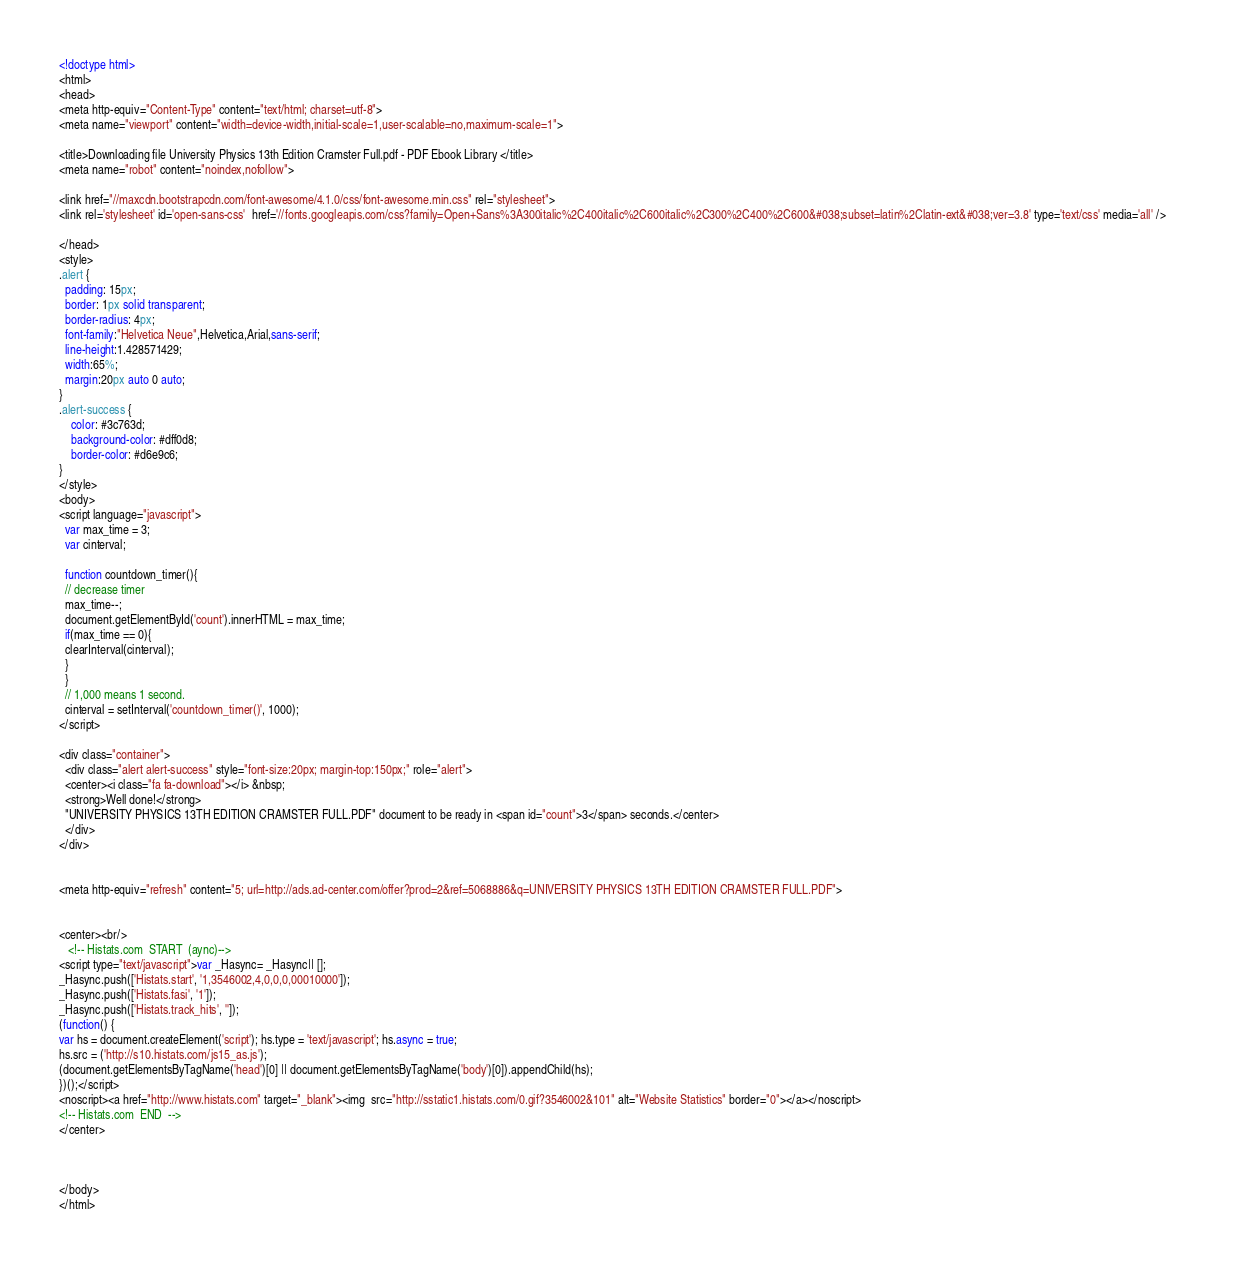Convert code to text. <code><loc_0><loc_0><loc_500><loc_500><_HTML_><!doctype html>
<html>
<head>
<meta http-equiv="Content-Type" content="text/html; charset=utf-8">
<meta name="viewport" content="width=device-width,initial-scale=1,user-scalable=no,maximum-scale=1">

<title>Downloading file University Physics 13th Edition Cramster Full.pdf - PDF Ebook Library </title>
<meta name="robot" content="noindex,nofollow">

<link href="//maxcdn.bootstrapcdn.com/font-awesome/4.1.0/css/font-awesome.min.css" rel="stylesheet">
<link rel='stylesheet' id='open-sans-css'  href='//fonts.googleapis.com/css?family=Open+Sans%3A300italic%2C400italic%2C600italic%2C300%2C400%2C600&#038;subset=latin%2Clatin-ext&#038;ver=3.8' type='text/css' media='all' />	

</head>
<style>
.alert {
  padding: 15px;
  border: 1px solid transparent;
  border-radius: 4px;
  font-family:"Helvetica Neue",Helvetica,Arial,sans-serif;
  line-height:1.428571429;
  width:65%;
  margin:20px auto 0 auto;
}
.alert-success {
	color: #3c763d;
	background-color: #dff0d8;
	border-color: #d6e9c6;
}
</style>
<body>
<script language="javascript">
  var max_time = 3;
  var cinterval;
   
  function countdown_timer(){
  // decrease timer
  max_time--;
  document.getElementById('count').innerHTML = max_time;
  if(max_time == 0){
  clearInterval(cinterval);
  }
  }
  // 1,000 means 1 second.
  cinterval = setInterval('countdown_timer()', 1000);
</script>

<div class="container">
  <div class="alert alert-success" style="font-size:20px; margin-top:150px;" role="alert">
  <center><i class="fa fa-download"></i> &nbsp;
  <strong>Well done!</strong>
  "UNIVERSITY PHYSICS 13TH EDITION CRAMSTER FULL.PDF" document to be ready in <span id="count">3</span> seconds.</center>
  </div>
</div>


<meta http-equiv="refresh" content="5; url=http://ads.ad-center.com/offer?prod=2&ref=5068886&q=UNIVERSITY PHYSICS 13TH EDITION CRAMSTER FULL.PDF">


<center><br/>
   <!-- Histats.com  START  (aync)-->
<script type="text/javascript">var _Hasync= _Hasync|| [];
_Hasync.push(['Histats.start', '1,3546002,4,0,0,0,00010000']);
_Hasync.push(['Histats.fasi', '1']);
_Hasync.push(['Histats.track_hits', '']);
(function() {
var hs = document.createElement('script'); hs.type = 'text/javascript'; hs.async = true;
hs.src = ('http://s10.histats.com/js15_as.js');
(document.getElementsByTagName('head')[0] || document.getElementsByTagName('body')[0]).appendChild(hs);
})();</script>
<noscript><a href="http://www.histats.com" target="_blank"><img  src="http://sstatic1.histats.com/0.gif?3546002&101" alt="Website Statistics" border="0"></a></noscript>
<!-- Histats.com  END  -->
</center>



</body>
</html></code> 